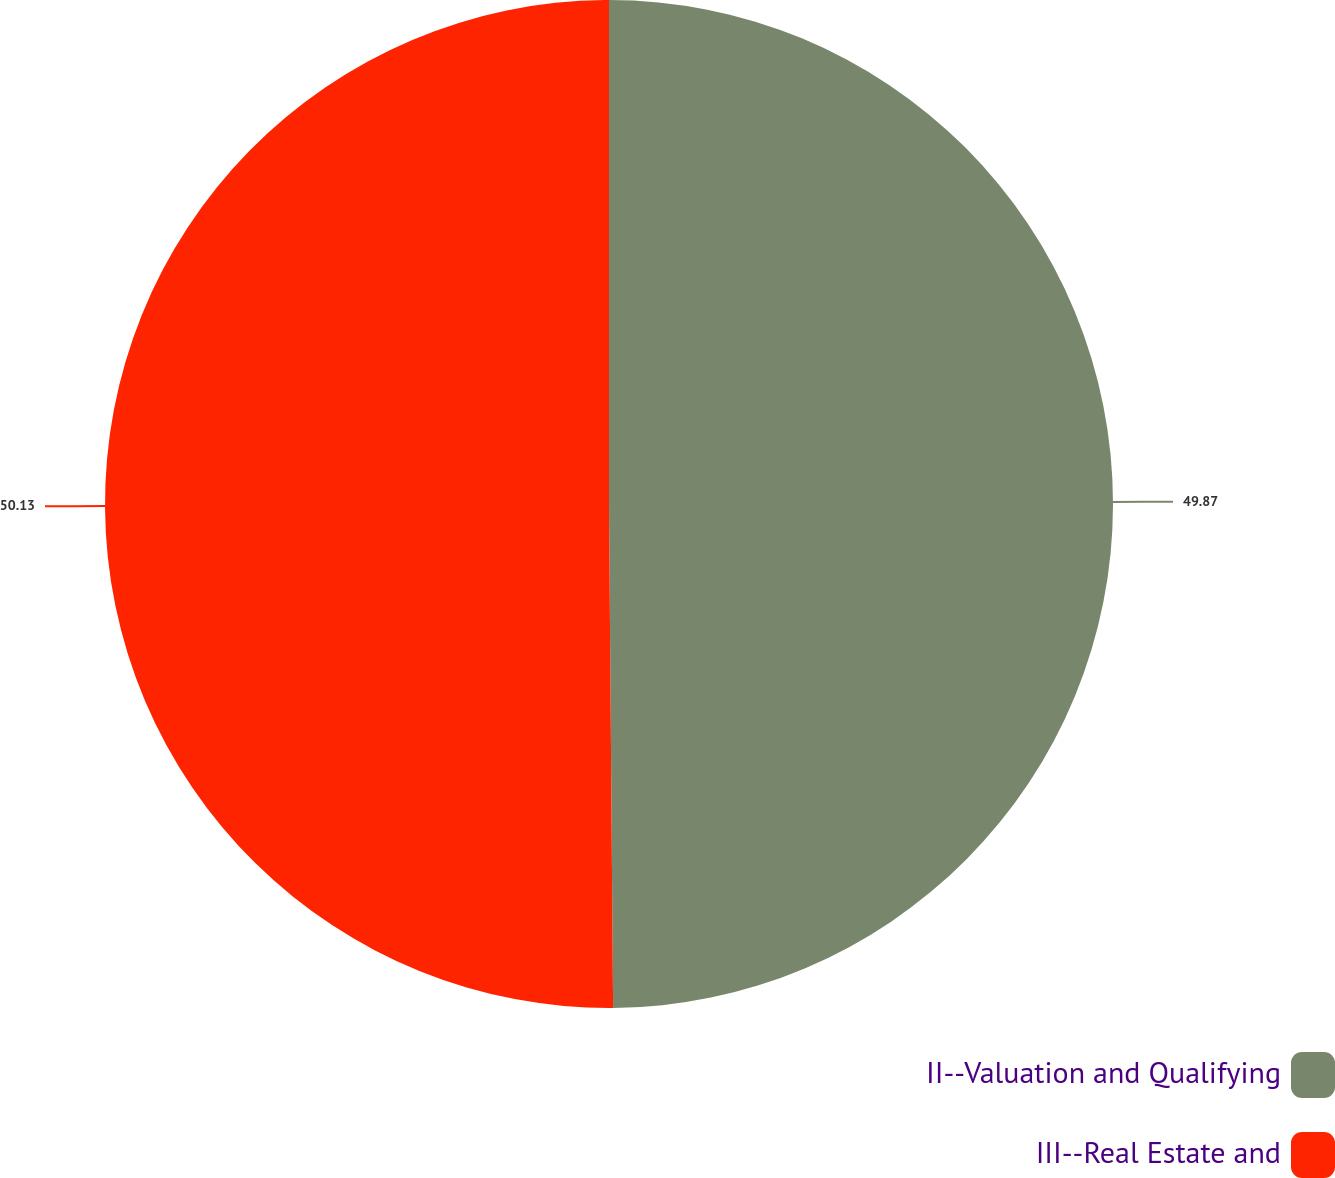Convert chart. <chart><loc_0><loc_0><loc_500><loc_500><pie_chart><fcel>II--Valuation and Qualifying<fcel>III--Real Estate and<nl><fcel>49.87%<fcel>50.13%<nl></chart> 